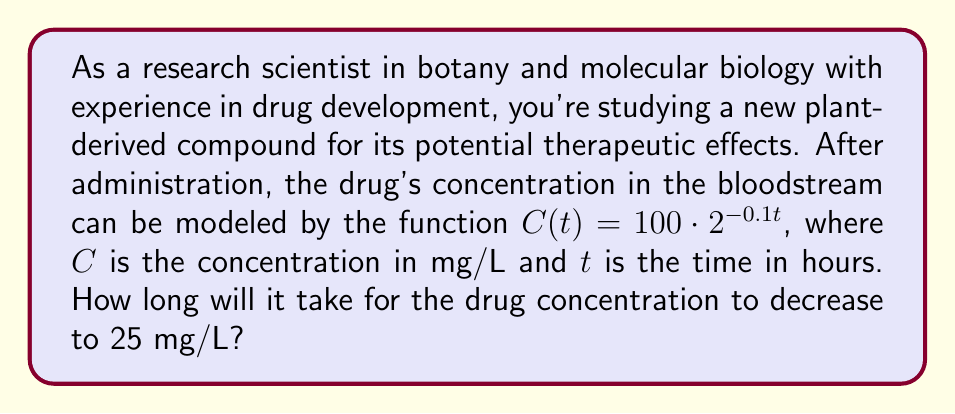Give your solution to this math problem. To solve this problem, we need to use the given logarithmic function and solve for t when C(t) = 25 mg/L.

1) Start with the given function:
   $C(t) = 100 \cdot 2^{-0.1t}$

2) Set C(t) equal to 25 mg/L:
   $25 = 100 \cdot 2^{-0.1t}$

3) Divide both sides by 100:
   $0.25 = 2^{-0.1t}$

4) Take the logarithm (base 2) of both sides:
   $\log_2(0.25) = \log_2(2^{-0.1t})$

5) Simplify the right side using the logarithm property $\log_a(a^x) = x$:
   $\log_2(0.25) = -0.1t$

6) Solve for t:
   $t = -\frac{\log_2(0.25)}{0.1}$

7) Simplify:
   $\log_2(0.25) = \log_2(\frac{1}{4}) = -2$
   
   $t = -\frac{-2}{0.1} = 20$

Therefore, it will take 20 hours for the drug concentration to decrease to 25 mg/L.
Answer: 20 hours 